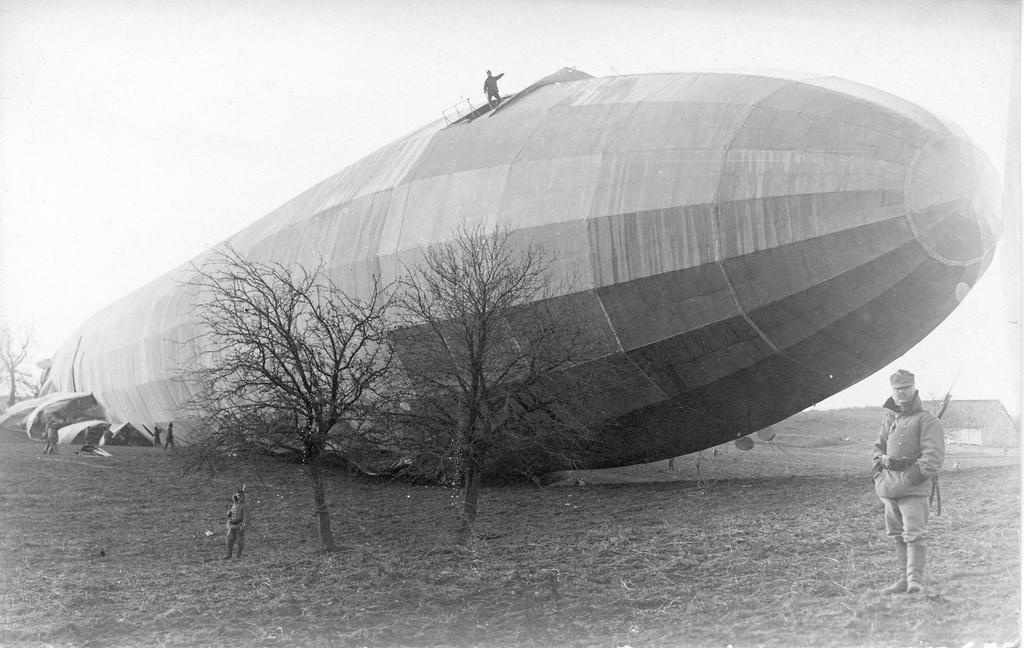What is happening in the image? There are people standing in the image, including one person on top of an airship wreck. What can be seen in the background of the image? There are trees with dry branches in the background. What is the main object in the foreground of the image? The main object in the foreground of the image is an airship wreck. What type of liquid is being served at the zoo in the image? There is no zoo or liquid being served in the image; it features people standing near an airship wreck. Are the people wearing stockings in the image? There is no mention of stockings or any clothing details in the image, so it cannot be determined from the image. 